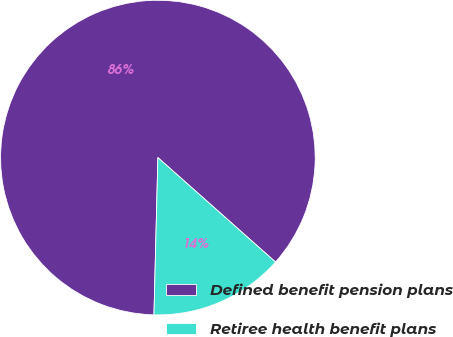Convert chart. <chart><loc_0><loc_0><loc_500><loc_500><pie_chart><fcel>Defined benefit pension plans<fcel>Retiree health benefit plans<nl><fcel>86.16%<fcel>13.84%<nl></chart> 